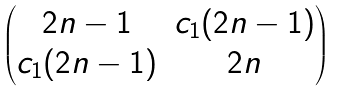<formula> <loc_0><loc_0><loc_500><loc_500>\begin{pmatrix} 2 n - 1 & c _ { 1 } ( 2 n - 1 ) \\ c _ { 1 } ( 2 n - 1 ) & 2 n \end{pmatrix}</formula> 